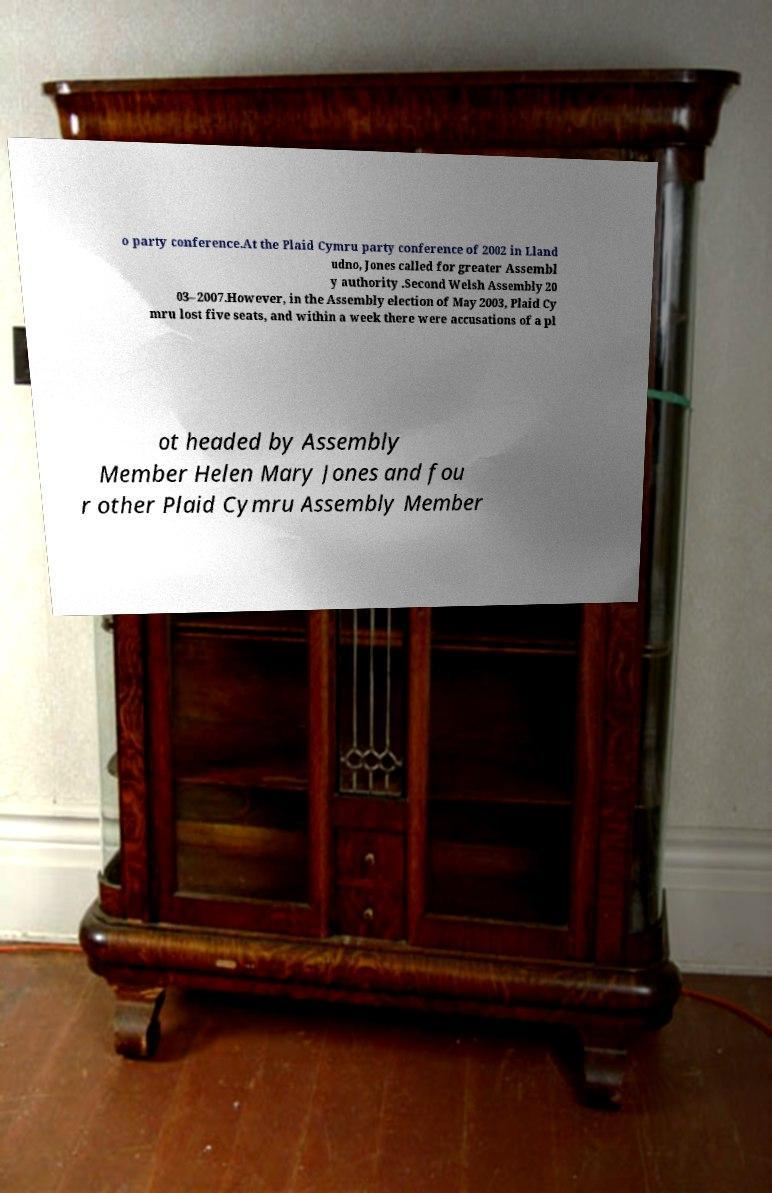Please read and relay the text visible in this image. What does it say? o party conference.At the Plaid Cymru party conference of 2002 in Lland udno, Jones called for greater Assembl y authority .Second Welsh Assembly 20 03–2007.However, in the Assembly election of May 2003, Plaid Cy mru lost five seats, and within a week there were accusations of a pl ot headed by Assembly Member Helen Mary Jones and fou r other Plaid Cymru Assembly Member 